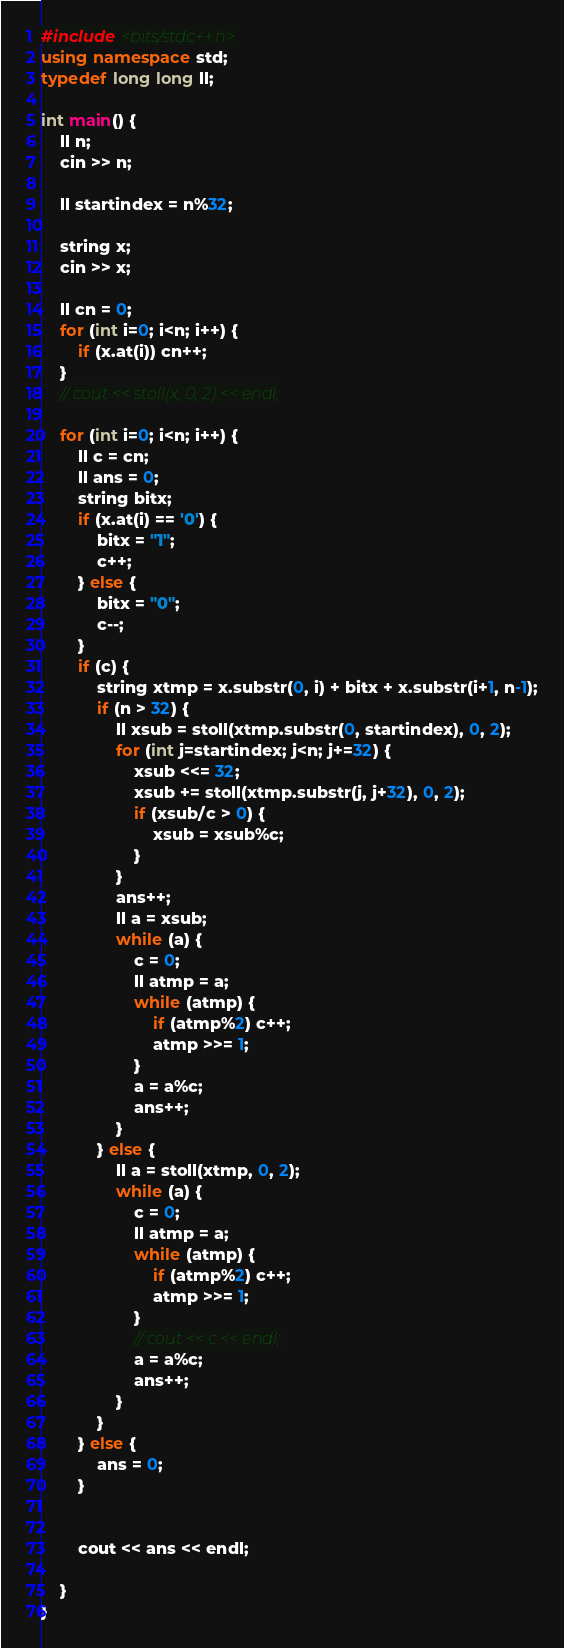Convert code to text. <code><loc_0><loc_0><loc_500><loc_500><_C++_>#include <bits/stdc++.h>
using namespace std;
typedef long long ll;

int main() {
    ll n;
    cin >> n;

    ll startindex = n%32;

    string x;
    cin >> x;

    ll cn = 0;
    for (int i=0; i<n; i++) {
        if (x.at(i)) cn++;
    }
    // cout << stoll(x, 0, 2) << endl;

    for (int i=0; i<n; i++) {
        ll c = cn;
        ll ans = 0;
        string bitx;
        if (x.at(i) == '0') {
            bitx = "1";
            c++;
        } else {
            bitx = "0";
            c--;
        }
        if (c) {
            string xtmp = x.substr(0, i) + bitx + x.substr(i+1, n-1);
            if (n > 32) {
                ll xsub = stoll(xtmp.substr(0, startindex), 0, 2);
                for (int j=startindex; j<n; j+=32) {
                    xsub <<= 32;
                    xsub += stoll(xtmp.substr(j, j+32), 0, 2);
                    if (xsub/c > 0) {
                        xsub = xsub%c;
                    }
                }
                ans++;
                ll a = xsub;
                while (a) {
                    c = 0;
                    ll atmp = a;
                    while (atmp) {
                        if (atmp%2) c++;
                        atmp >>= 1;
                    }
                    a = a%c;
                    ans++;
                }
            } else {
                ll a = stoll(xtmp, 0, 2);
                while (a) {
                    c = 0;
                    ll atmp = a;
                    while (atmp) {
                        if (atmp%2) c++;
                        atmp >>= 1;
                    }
                    // cout << c << endl;
                    a = a%c;
                    ans++;
                }
            }
        } else {
            ans = 0;
        }
        
        
        cout << ans << endl;

    }
}</code> 